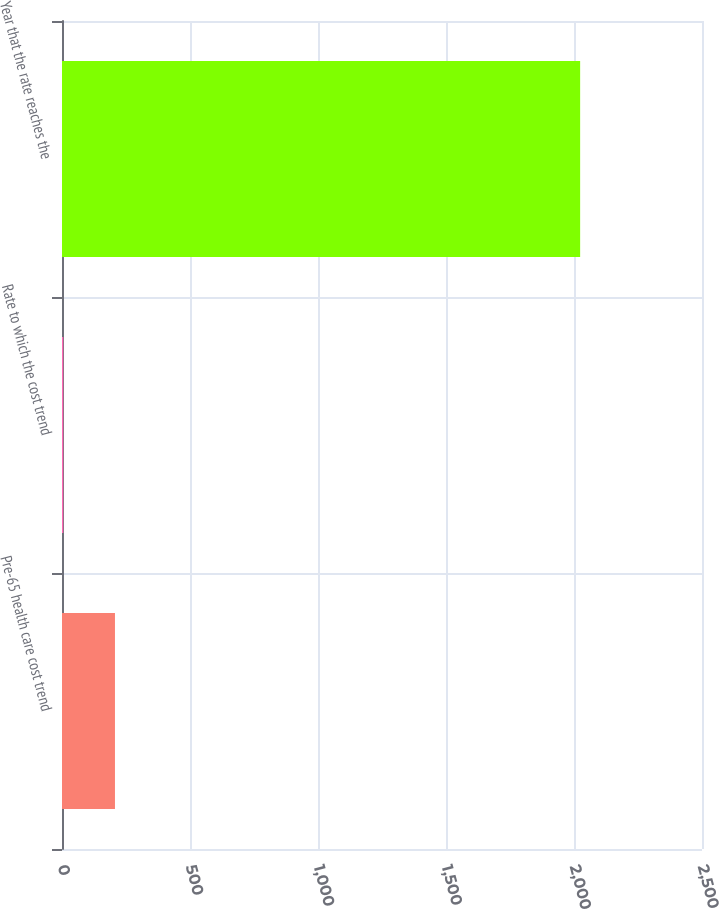<chart> <loc_0><loc_0><loc_500><loc_500><bar_chart><fcel>Pre-65 health care cost trend<fcel>Rate to which the cost trend<fcel>Year that the rate reaches the<nl><fcel>206.9<fcel>5<fcel>2024<nl></chart> 